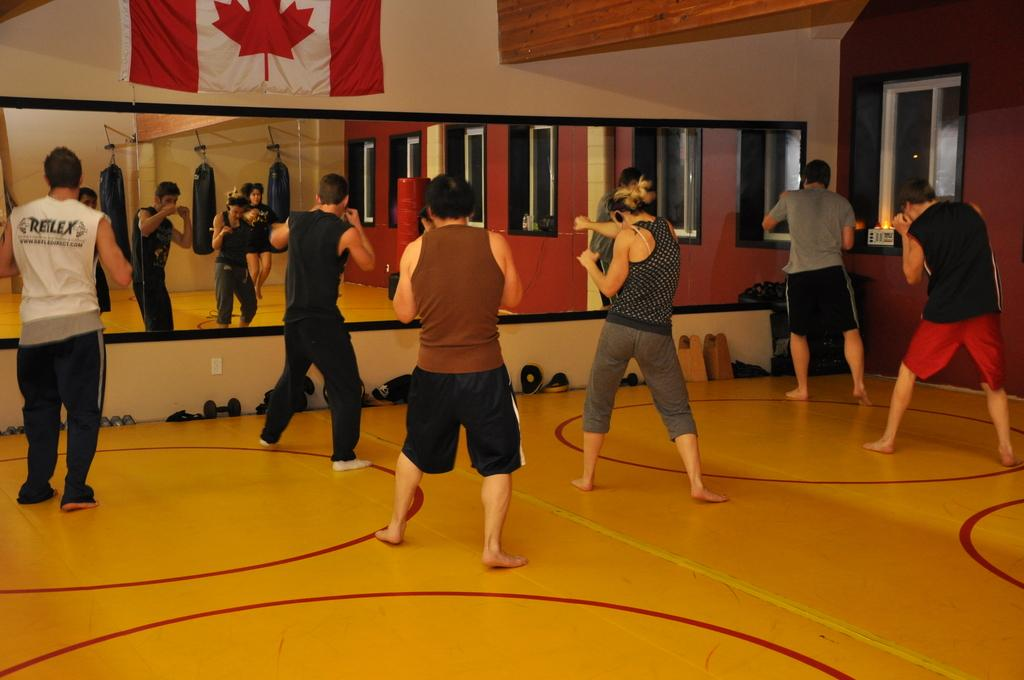How many people are in the image? There are persons visible in the image. What is the location of the persons in the image? The persons are in front of a mirror. Where is the mirror located? The mirror is attached to a wall. What is on the wall besides the mirror? There is a cloth on the wall. What can be seen on the right side of the image? There is a window on the right side of the image. What type of steel is used to make the frame of the mirror in the image? There is no information about the material used to make the frame of the mirror in the image. --- Facts: 1. There is a person holding a book in the image. 2. The book has a blue cover. 3. The person is sitting on a chair. 4. There is a table next to the chair. 5. The table has a lamp on it. Absurd Topics: elephant, ocean, volcano Conversation: What is the person holding in the image? The person is holding a book in the image. What is the color of the book's cover? The book has a blue cover. What is the person sitting on in the image? The person is sitting on a chair. What is next to the chair in the image? There is a table next to the chair. What is on the table in the image? The table has a lamp on it. Reasoning: Let's think step by step in order to produce the conversation. We start by identifying the main subject in the image, which is the person holding a book. Then, we expand the conversation to include other items that are also visible, such as the book's color, the chair, the table, and the lamp. Each question is designed to elicit a specific detail about the image that is known from the provided facts. Absurd Question/Answer: Can you see an elephant swimming in the ocean in the image? No, there is no elephant or ocean present in the image. 